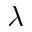Convert formula to latex. <formula><loc_0><loc_0><loc_500><loc_500>\lambda</formula> 